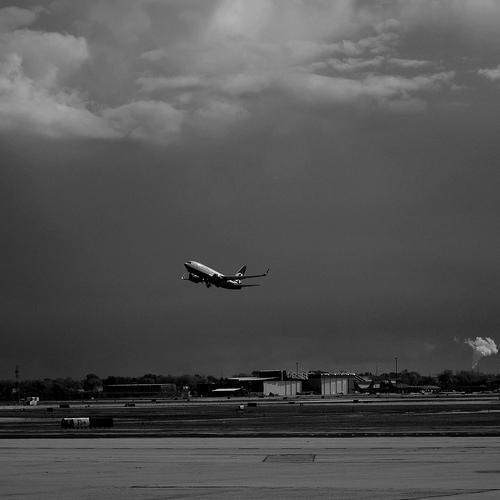How many planes are in this photo?
Give a very brief answer. 1. How many wings does the plane have?
Give a very brief answer. 2. 